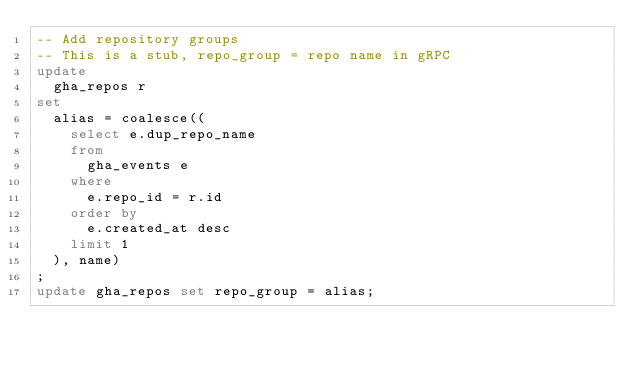Convert code to text. <code><loc_0><loc_0><loc_500><loc_500><_SQL_>-- Add repository groups
-- This is a stub, repo_group = repo name in gRPC
update
  gha_repos r
set
  alias = coalesce((
    select e.dup_repo_name
    from
      gha_events e
    where
      e.repo_id = r.id
    order by
      e.created_at desc
    limit 1
  ), name)
;
update gha_repos set repo_group = alias;
</code> 